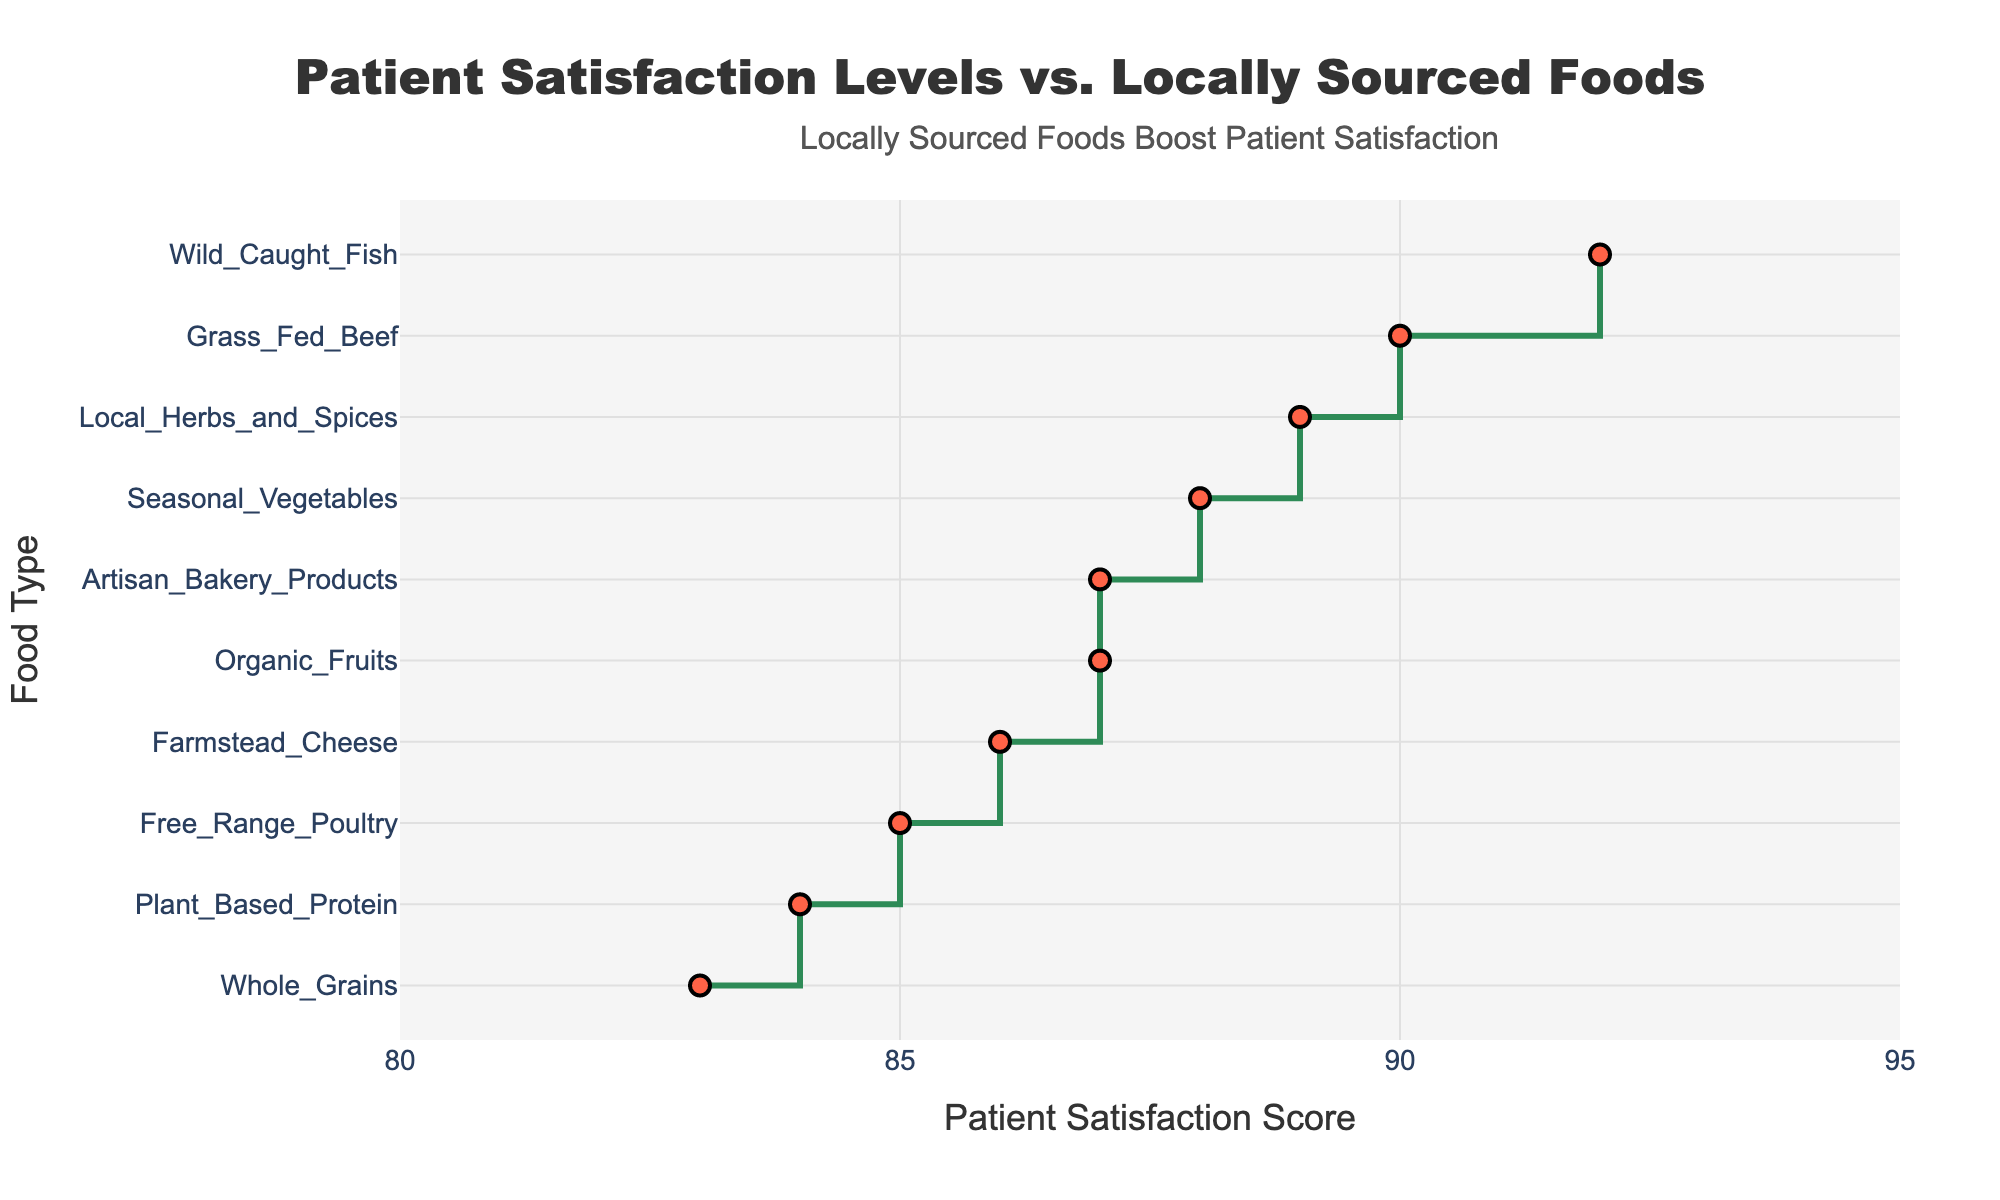What's the title of the figure? The title of the figure is located at the top of the plot. It is typically written in larger font and centered for visibility.
Answer: Patient Satisfaction Levels vs. Locally Sourced Foods Which food type has the highest patient satisfaction score? Locate the highest point on the x-axis, which corresponds with the directly aligned food type on the y-axis.
Answer: Wild Caught Fish How many food types have a satisfaction score above 85? Identify all points on the plot that are positioned on the x-axis above the score of 85. Count these points.
Answer: 7 What is the range of patient satisfaction scores shown in the plot? The range is determined by the difference between the highest and lowest satisfaction scores on the x-axis. Identify these two points and calculate: 92 (highest) - 83 (lowest).
Answer: 9 What is the median satisfaction score of the listed food types? Sort the satisfaction scores in ascending order, find the middle value since there is an odd number of data points (10/2 = 5), which is the average of the 5th and 6th values. The sorted scores are [83, 84, 85, 86, 87, 87, 88, 89, 90, 92]. The median is the mean of the 5th and 6th values: (87+87)/2 = 87.
Answer: 87 What is the overall trend observed in the patient satisfaction levels when different types of locally sourced foods are served? Review the general direction of points in the plot to determine if they largely increase, decrease, or remain constant.
Answer: Increasing Which two food types have the closest satisfaction score? Look for the smallest gap between any two points on the x-axis, which corresponds to their satisfaction scores.
Answer: Organic Fruits and Artisan Bakery Products How do satisfaction scores for Grass Fed Beef and Farmstead Cheese compare? Identify the scores on the x-axis corresponding to these food types. Grass Fed Beef has a score of 90, and Farmstead Cheese has a score of 86.
Answer: Grass Fed Beef is higher What is the difference in satisfaction scores between Organic Fruits and Whole Grains? Subtract the satisfaction score of Whole Grains from that of Organic Fruits. Organic Fruits: 87, Whole Grains: 83. Calculate 87 - 83.
Answer: 4 Which food type falls exactly at the midpoint between Wild Caught Fish and Free Range Poultry? Find the satisfaction scores of Wild Caught Fish (92) and Free Range Poultry (85). The midpoint is (92+85)/2 = 88.5. Check which food type is closest to this score. Seasonal Vegetables have a score of 88, making it the closest.
Answer: Seasonal Vegetables 